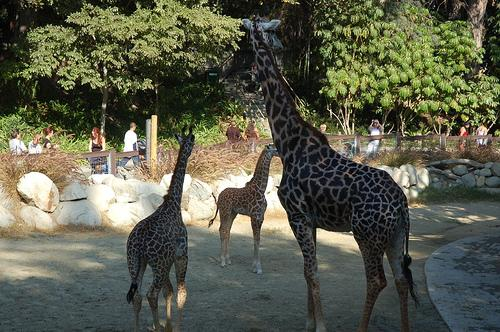How many giraffes can be seen in the image and what do they appear to be doing? There are three giraffes in the image - an adult and two young ones - who seem to be watching the people at the national park or zoo. What is the primary task that the image is suitable for evaluating? The primary task that the image is suitable for evaluating is object detection and interaction analysis, as it involves multiple objects and their relations to one another. Analyze and describe the interaction between the objects and living creatures in the image. The giraffes and people are watching each other, suggesting a mutual curiosity, while the giraffes are also interacting with their environment by standing on the dirt and near green trees. Assess the image quality based on the object positioning and level of detail provided in the description. The image quality seems to be reasonably high, as the objects are well-defined and their positioning appears natural. The description also provides a good level of detail for a coherent understanding. Examine the background of the image and detail any noticeable landscape features. The background consists of green trees in the national park, a wooden and wire fence, stacked white stones in front of the fence, and some trees in the distance. Identify the main focus of the picture and describe what is happening. The image features three giraffes, including one adult and two young ones, in a national park or zoo where people are watching them, and the giraffes are observing people too. What are the people in the image doing, and can you provide a description of some of the individuals? The people in the image are visiting the zoo and watching the giraffes. Some individuals include a woman with red hair wearing a black top and a man wearing a red shirt. What is the general sentiment conveyed by this image? The sentiment conveyed by the image is a mixture of curiosity, interaction, and enjoyment, as the giraffes and people observe each other in the national park or zoo setting. Count the number of giraffes and people visible in the picture. There are three giraffes and several people visible in the picture, but the exact number of people cannot be determined from the information provided. Identify any signs of man-made structures or objects within the image. There is a wooden and wire fence, the top portion of it is visible, and large white stones stacked in front of the fence. Detect the presence of any text in the image. No text detected in the image What type of interaction do the people and giraffes display? People observing the giraffes and giraffes watching the people Can you see the baby elephant in the image? No, it's not mentioned in the image. Provide a general description for the image. People visiting a zoo observe three giraffes behind a wooden fence, with trees in the background. How many white stones are there on the ground? Multiple large white stones stacked in front of the fence Detect all the objects in the image. Three giraffes, people, wooden fence, white stones, trees, wire fence top, puddles, red shirt, black top, white top Identify any apparent anomalies in the image. No significant anomalies detected Is the fence made of wood or metal? Wooden fence with a wire top How good is the photo quality? Moderate quality with clear objects and details What are the main emotions present in the image? Curiosity, excitement, and interest What is the color of the shirt that the man is wearing? Red Are the baby giraffes close to their mother? Yes, the baby giraffe is near her mother What can be seen in the distance other than the trees? Tracks and small puddles of water behind them Describe the relationship between the people and the fence. The people are on the other side of the fence observing the giraffes Count the number of giraffes in the image. Three giraffes: one adult and two young What is the location of the small puddles of water? Behind the tracks, close to the fence Describe the setting of the image. A zoo with giraffes in the enclosure, trees in the surrounding area, and people observing What type of fence separates the visitors from the giraffes? Wooden and wire fence List the attributes of the woman with red hair. Red hair, wearing a black top Describe the colors and clothing of the people in the image. Woman with red hair, black and white tops, man with red shirt Identify the different zones in the image. Giraffe area with dirt, zoo visitors area, fence separating areas, trees in background 